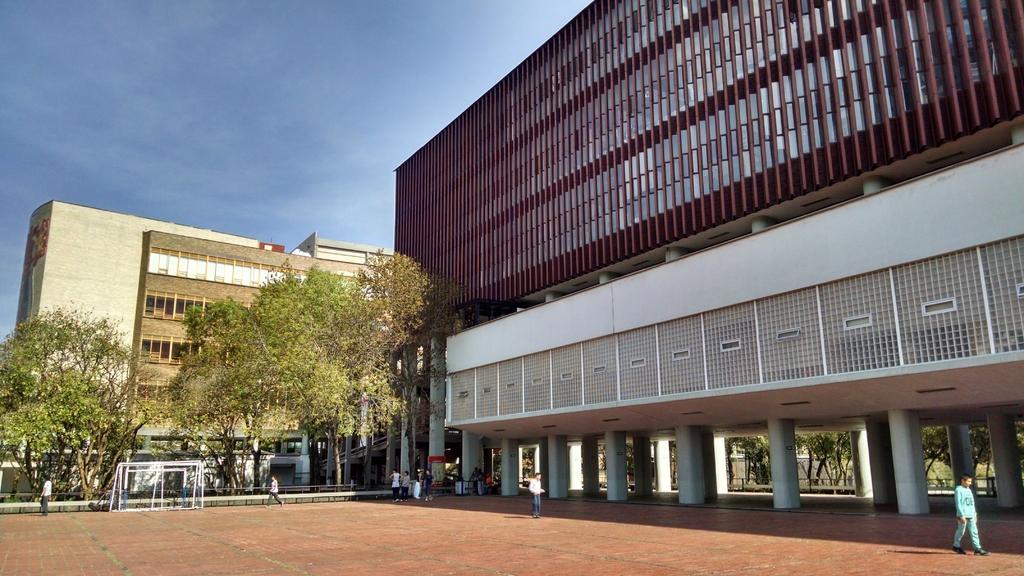Can you describe this image briefly? In this image, on the right side, we can see a building, pillars. On the right side, we can also see a man walking on the road. In the middle of the image, we can see a person. In the background, we can see a group of people, pole, trees, building. At the top, we can see a sky, at the bottom, we can see a land. 